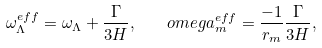<formula> <loc_0><loc_0><loc_500><loc_500>\omega _ { \Lambda } ^ { e f f } = \omega _ { \Lambda } + \frac { \Gamma } { 3 H } , \quad o m e g a _ { m } ^ { e f f } = \frac { - 1 } { r _ { m } } \frac { \Gamma } { 3 H } ,</formula> 